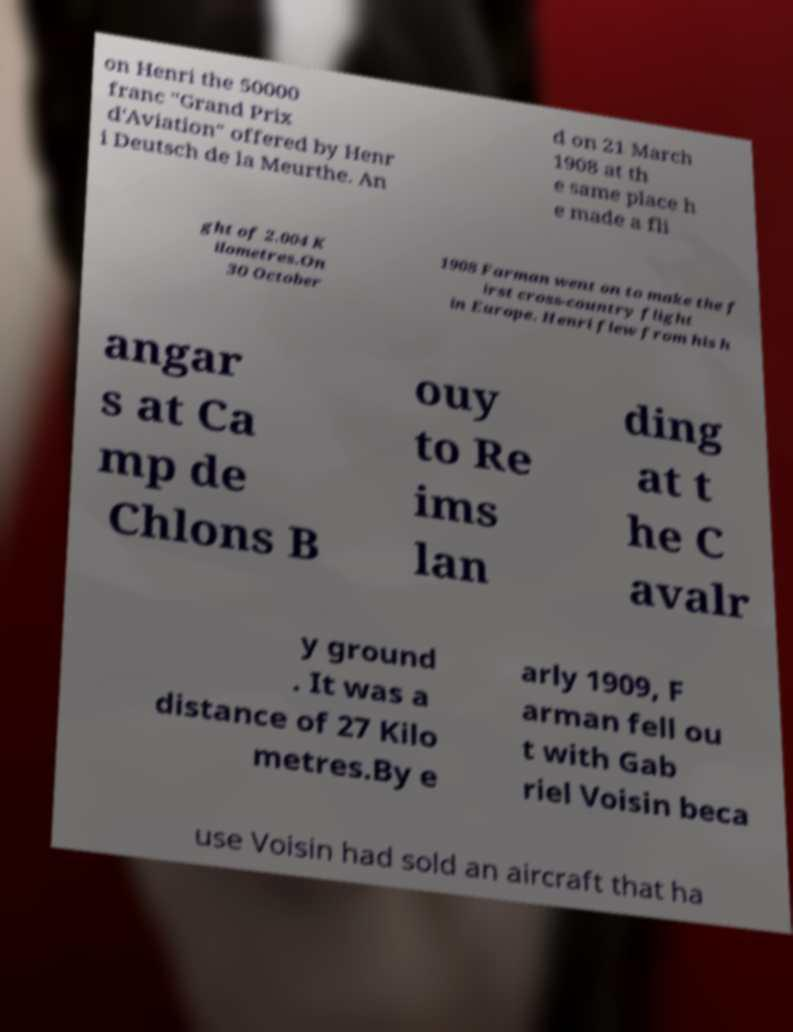Please read and relay the text visible in this image. What does it say? on Henri the 50000 franc "Grand Prix d'Aviation" offered by Henr i Deutsch de la Meurthe. An d on 21 March 1908 at th e same place h e made a fli ght of 2.004 K ilometres.On 30 October 1908 Farman went on to make the f irst cross-country flight in Europe. Henri flew from his h angar s at Ca mp de Chlons B ouy to Re ims lan ding at t he C avalr y ground . It was a distance of 27 Kilo metres.By e arly 1909, F arman fell ou t with Gab riel Voisin beca use Voisin had sold an aircraft that ha 